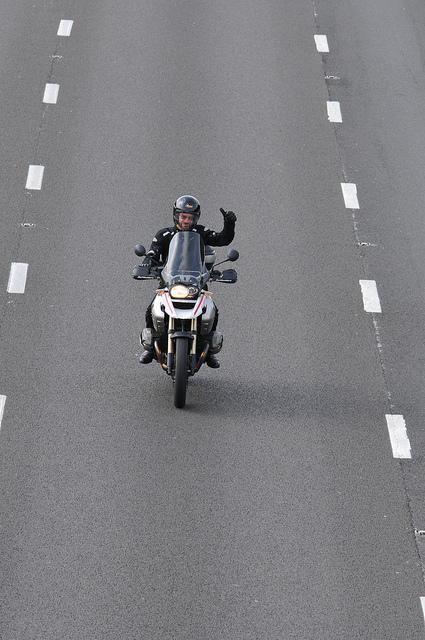How many bikes are on the road?
Short answer required. 1. Is anyone sitting in this photo?
Give a very brief answer. Yes. Is he wearing head protection?
Answer briefly. Yes. Why is the motorcycle stopped?
Concise answer only. It's not. Which hand is the man raising?
Be succinct. Left. 